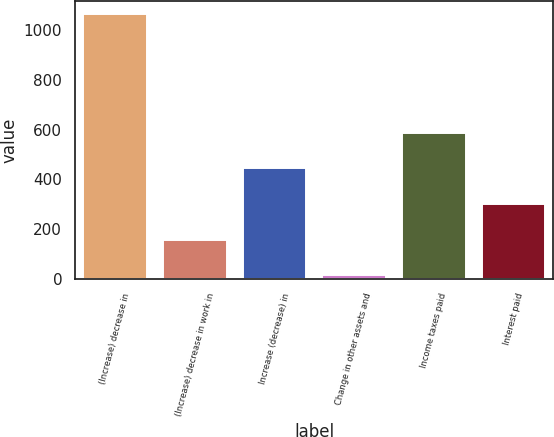<chart> <loc_0><loc_0><loc_500><loc_500><bar_chart><fcel>(Increase) decrease in<fcel>(Increase) decrease in work in<fcel>Increase (decrease) in<fcel>Change in other assets and<fcel>Income taxes paid<fcel>Interest paid<nl><fcel>1063.6<fcel>157.96<fcel>443.68<fcel>15.1<fcel>586.54<fcel>300.82<nl></chart> 